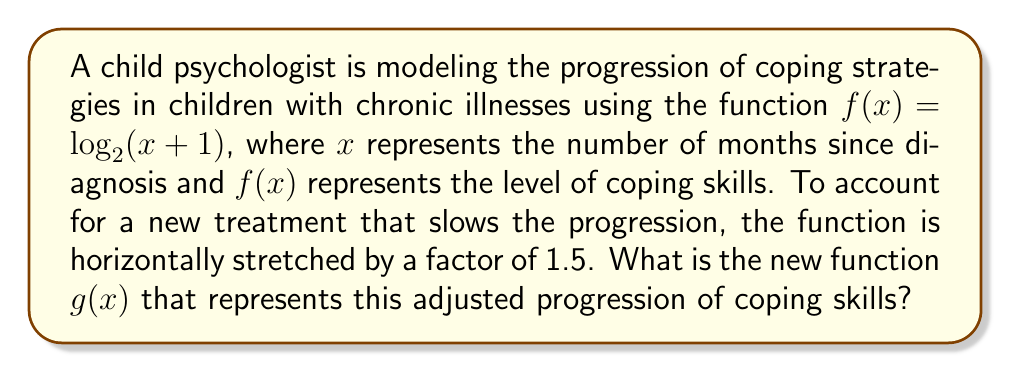Teach me how to tackle this problem. To solve this problem, we need to apply a horizontal stretch to the original function. Here's the step-by-step process:

1) The general form of a horizontal stretch is:
   $g(x) = f(\frac{x}{k})$, where $k$ is the stretch factor

2) In this case, $k = 1.5$ and $f(x) = \log_2(x+1)$

3) Substituting these into the general form:
   $g(x) = f(\frac{x}{1.5})$

4) Now, replace $f$ with its actual function:
   $g(x) = \log_2(\frac{x}{1.5}+1)$

5) To simplify this further, we can manipulate the argument of the logarithm:
   $g(x) = \log_2(\frac{x+1.5}{1.5})$

6) Using the properties of logarithms, we can rewrite this as:
   $g(x) = \log_2(x+1.5) - \log_2(1.5)$

This is the final form of the new function $g(x)$ that represents the adjusted progression of coping skills.
Answer: $g(x) = \log_2(x+1.5) - \log_2(1.5)$ 